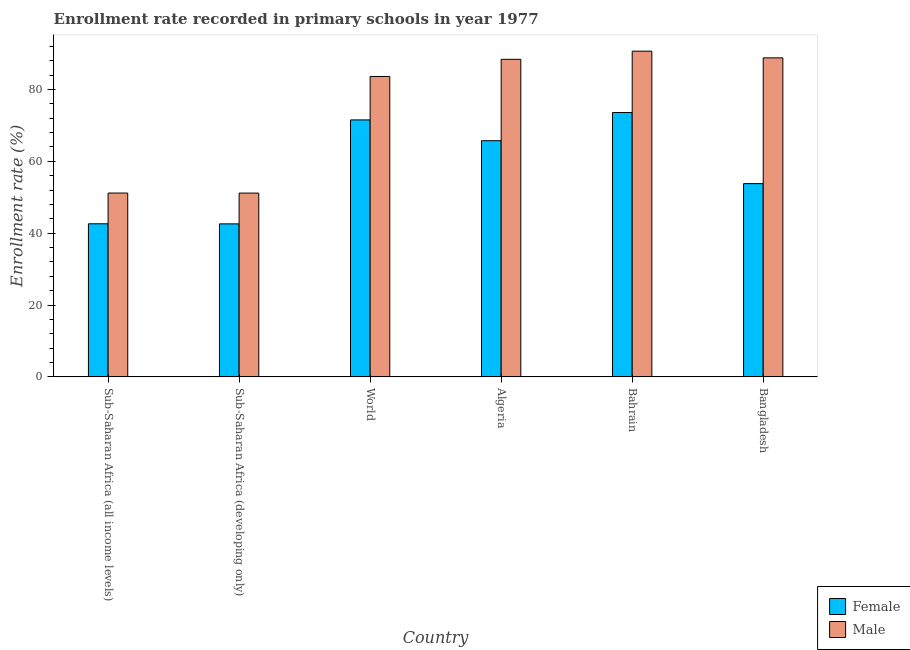How many different coloured bars are there?
Your answer should be very brief. 2. How many bars are there on the 3rd tick from the left?
Provide a short and direct response. 2. What is the label of the 2nd group of bars from the left?
Offer a terse response. Sub-Saharan Africa (developing only). What is the enrollment rate of female students in Bahrain?
Give a very brief answer. 73.57. Across all countries, what is the maximum enrollment rate of male students?
Provide a succinct answer. 90.65. Across all countries, what is the minimum enrollment rate of female students?
Your answer should be compact. 42.58. In which country was the enrollment rate of male students maximum?
Give a very brief answer. Bahrain. In which country was the enrollment rate of male students minimum?
Your answer should be very brief. Sub-Saharan Africa (developing only). What is the total enrollment rate of male students in the graph?
Give a very brief answer. 453.72. What is the difference between the enrollment rate of female students in Bahrain and that in Sub-Saharan Africa (all income levels)?
Provide a succinct answer. 30.97. What is the difference between the enrollment rate of male students in Sub-Saharan Africa (developing only) and the enrollment rate of female students in World?
Keep it short and to the point. -20.36. What is the average enrollment rate of male students per country?
Your answer should be very brief. 75.62. What is the difference between the enrollment rate of male students and enrollment rate of female students in Sub-Saharan Africa (developing only)?
Keep it short and to the point. 8.56. In how many countries, is the enrollment rate of female students greater than 44 %?
Ensure brevity in your answer.  4. What is the ratio of the enrollment rate of female students in Bahrain to that in Sub-Saharan Africa (developing only)?
Give a very brief answer. 1.73. What is the difference between the highest and the second highest enrollment rate of female students?
Offer a terse response. 2.06. What is the difference between the highest and the lowest enrollment rate of male students?
Your response must be concise. 39.5. In how many countries, is the enrollment rate of male students greater than the average enrollment rate of male students taken over all countries?
Provide a short and direct response. 4. What does the 1st bar from the left in Bahrain represents?
Give a very brief answer. Female. How many bars are there?
Your answer should be compact. 12. Does the graph contain any zero values?
Offer a very short reply. No. Does the graph contain grids?
Provide a short and direct response. No. Where does the legend appear in the graph?
Keep it short and to the point. Bottom right. How many legend labels are there?
Make the answer very short. 2. How are the legend labels stacked?
Your response must be concise. Vertical. What is the title of the graph?
Provide a succinct answer. Enrollment rate recorded in primary schools in year 1977. Does "Money lenders" appear as one of the legend labels in the graph?
Offer a very short reply. No. What is the label or title of the Y-axis?
Offer a terse response. Enrollment rate (%). What is the Enrollment rate (%) in Female in Sub-Saharan Africa (all income levels)?
Give a very brief answer. 42.6. What is the Enrollment rate (%) of Male in Sub-Saharan Africa (all income levels)?
Keep it short and to the point. 51.16. What is the Enrollment rate (%) of Female in Sub-Saharan Africa (developing only)?
Provide a short and direct response. 42.58. What is the Enrollment rate (%) in Male in Sub-Saharan Africa (developing only)?
Offer a terse response. 51.15. What is the Enrollment rate (%) of Female in World?
Offer a very short reply. 71.51. What is the Enrollment rate (%) of Male in World?
Offer a terse response. 83.6. What is the Enrollment rate (%) in Female in Algeria?
Keep it short and to the point. 65.73. What is the Enrollment rate (%) in Male in Algeria?
Your answer should be very brief. 88.38. What is the Enrollment rate (%) in Female in Bahrain?
Provide a short and direct response. 73.57. What is the Enrollment rate (%) of Male in Bahrain?
Offer a terse response. 90.65. What is the Enrollment rate (%) in Female in Bangladesh?
Ensure brevity in your answer.  53.78. What is the Enrollment rate (%) of Male in Bangladesh?
Your answer should be very brief. 88.78. Across all countries, what is the maximum Enrollment rate (%) in Female?
Offer a very short reply. 73.57. Across all countries, what is the maximum Enrollment rate (%) of Male?
Offer a very short reply. 90.65. Across all countries, what is the minimum Enrollment rate (%) of Female?
Provide a short and direct response. 42.58. Across all countries, what is the minimum Enrollment rate (%) of Male?
Ensure brevity in your answer.  51.15. What is the total Enrollment rate (%) in Female in the graph?
Keep it short and to the point. 349.77. What is the total Enrollment rate (%) of Male in the graph?
Your answer should be compact. 453.72. What is the difference between the Enrollment rate (%) in Female in Sub-Saharan Africa (all income levels) and that in Sub-Saharan Africa (developing only)?
Provide a succinct answer. 0.02. What is the difference between the Enrollment rate (%) of Male in Sub-Saharan Africa (all income levels) and that in Sub-Saharan Africa (developing only)?
Your response must be concise. 0.01. What is the difference between the Enrollment rate (%) of Female in Sub-Saharan Africa (all income levels) and that in World?
Keep it short and to the point. -28.91. What is the difference between the Enrollment rate (%) in Male in Sub-Saharan Africa (all income levels) and that in World?
Give a very brief answer. -32.44. What is the difference between the Enrollment rate (%) of Female in Sub-Saharan Africa (all income levels) and that in Algeria?
Keep it short and to the point. -23.12. What is the difference between the Enrollment rate (%) of Male in Sub-Saharan Africa (all income levels) and that in Algeria?
Offer a very short reply. -37.22. What is the difference between the Enrollment rate (%) in Female in Sub-Saharan Africa (all income levels) and that in Bahrain?
Your answer should be compact. -30.97. What is the difference between the Enrollment rate (%) of Male in Sub-Saharan Africa (all income levels) and that in Bahrain?
Offer a very short reply. -39.49. What is the difference between the Enrollment rate (%) in Female in Sub-Saharan Africa (all income levels) and that in Bangladesh?
Give a very brief answer. -11.18. What is the difference between the Enrollment rate (%) of Male in Sub-Saharan Africa (all income levels) and that in Bangladesh?
Give a very brief answer. -37.62. What is the difference between the Enrollment rate (%) of Female in Sub-Saharan Africa (developing only) and that in World?
Your answer should be very brief. -28.93. What is the difference between the Enrollment rate (%) in Male in Sub-Saharan Africa (developing only) and that in World?
Your answer should be very brief. -32.46. What is the difference between the Enrollment rate (%) of Female in Sub-Saharan Africa (developing only) and that in Algeria?
Make the answer very short. -23.14. What is the difference between the Enrollment rate (%) of Male in Sub-Saharan Africa (developing only) and that in Algeria?
Give a very brief answer. -37.23. What is the difference between the Enrollment rate (%) in Female in Sub-Saharan Africa (developing only) and that in Bahrain?
Your answer should be very brief. -30.99. What is the difference between the Enrollment rate (%) of Male in Sub-Saharan Africa (developing only) and that in Bahrain?
Offer a terse response. -39.5. What is the difference between the Enrollment rate (%) of Female in Sub-Saharan Africa (developing only) and that in Bangladesh?
Your response must be concise. -11.19. What is the difference between the Enrollment rate (%) of Male in Sub-Saharan Africa (developing only) and that in Bangladesh?
Your answer should be very brief. -37.63. What is the difference between the Enrollment rate (%) of Female in World and that in Algeria?
Give a very brief answer. 5.79. What is the difference between the Enrollment rate (%) in Male in World and that in Algeria?
Provide a succinct answer. -4.78. What is the difference between the Enrollment rate (%) of Female in World and that in Bahrain?
Offer a terse response. -2.06. What is the difference between the Enrollment rate (%) in Male in World and that in Bahrain?
Provide a succinct answer. -7.04. What is the difference between the Enrollment rate (%) of Female in World and that in Bangladesh?
Give a very brief answer. 17.73. What is the difference between the Enrollment rate (%) in Male in World and that in Bangladesh?
Your answer should be very brief. -5.18. What is the difference between the Enrollment rate (%) of Female in Algeria and that in Bahrain?
Your answer should be very brief. -7.84. What is the difference between the Enrollment rate (%) in Male in Algeria and that in Bahrain?
Keep it short and to the point. -2.27. What is the difference between the Enrollment rate (%) of Female in Algeria and that in Bangladesh?
Your answer should be compact. 11.95. What is the difference between the Enrollment rate (%) of Male in Algeria and that in Bangladesh?
Provide a succinct answer. -0.4. What is the difference between the Enrollment rate (%) of Female in Bahrain and that in Bangladesh?
Ensure brevity in your answer.  19.79. What is the difference between the Enrollment rate (%) in Male in Bahrain and that in Bangladesh?
Keep it short and to the point. 1.87. What is the difference between the Enrollment rate (%) of Female in Sub-Saharan Africa (all income levels) and the Enrollment rate (%) of Male in Sub-Saharan Africa (developing only)?
Your response must be concise. -8.55. What is the difference between the Enrollment rate (%) of Female in Sub-Saharan Africa (all income levels) and the Enrollment rate (%) of Male in World?
Your answer should be compact. -41. What is the difference between the Enrollment rate (%) of Female in Sub-Saharan Africa (all income levels) and the Enrollment rate (%) of Male in Algeria?
Offer a very short reply. -45.78. What is the difference between the Enrollment rate (%) in Female in Sub-Saharan Africa (all income levels) and the Enrollment rate (%) in Male in Bahrain?
Provide a short and direct response. -48.04. What is the difference between the Enrollment rate (%) of Female in Sub-Saharan Africa (all income levels) and the Enrollment rate (%) of Male in Bangladesh?
Make the answer very short. -46.18. What is the difference between the Enrollment rate (%) of Female in Sub-Saharan Africa (developing only) and the Enrollment rate (%) of Male in World?
Ensure brevity in your answer.  -41.02. What is the difference between the Enrollment rate (%) in Female in Sub-Saharan Africa (developing only) and the Enrollment rate (%) in Male in Algeria?
Keep it short and to the point. -45.8. What is the difference between the Enrollment rate (%) of Female in Sub-Saharan Africa (developing only) and the Enrollment rate (%) of Male in Bahrain?
Your response must be concise. -48.06. What is the difference between the Enrollment rate (%) in Female in Sub-Saharan Africa (developing only) and the Enrollment rate (%) in Male in Bangladesh?
Your answer should be very brief. -46.2. What is the difference between the Enrollment rate (%) in Female in World and the Enrollment rate (%) in Male in Algeria?
Your answer should be compact. -16.87. What is the difference between the Enrollment rate (%) of Female in World and the Enrollment rate (%) of Male in Bahrain?
Provide a short and direct response. -19.14. What is the difference between the Enrollment rate (%) in Female in World and the Enrollment rate (%) in Male in Bangladesh?
Provide a succinct answer. -17.27. What is the difference between the Enrollment rate (%) of Female in Algeria and the Enrollment rate (%) of Male in Bahrain?
Make the answer very short. -24.92. What is the difference between the Enrollment rate (%) of Female in Algeria and the Enrollment rate (%) of Male in Bangladesh?
Your response must be concise. -23.05. What is the difference between the Enrollment rate (%) in Female in Bahrain and the Enrollment rate (%) in Male in Bangladesh?
Give a very brief answer. -15.21. What is the average Enrollment rate (%) in Female per country?
Your answer should be very brief. 58.3. What is the average Enrollment rate (%) of Male per country?
Provide a short and direct response. 75.62. What is the difference between the Enrollment rate (%) in Female and Enrollment rate (%) in Male in Sub-Saharan Africa (all income levels)?
Keep it short and to the point. -8.56. What is the difference between the Enrollment rate (%) in Female and Enrollment rate (%) in Male in Sub-Saharan Africa (developing only)?
Provide a short and direct response. -8.56. What is the difference between the Enrollment rate (%) of Female and Enrollment rate (%) of Male in World?
Provide a short and direct response. -12.09. What is the difference between the Enrollment rate (%) of Female and Enrollment rate (%) of Male in Algeria?
Your response must be concise. -22.65. What is the difference between the Enrollment rate (%) of Female and Enrollment rate (%) of Male in Bahrain?
Your answer should be very brief. -17.08. What is the difference between the Enrollment rate (%) in Female and Enrollment rate (%) in Male in Bangladesh?
Your answer should be very brief. -35. What is the ratio of the Enrollment rate (%) of Male in Sub-Saharan Africa (all income levels) to that in Sub-Saharan Africa (developing only)?
Provide a short and direct response. 1. What is the ratio of the Enrollment rate (%) in Female in Sub-Saharan Africa (all income levels) to that in World?
Make the answer very short. 0.6. What is the ratio of the Enrollment rate (%) in Male in Sub-Saharan Africa (all income levels) to that in World?
Make the answer very short. 0.61. What is the ratio of the Enrollment rate (%) of Female in Sub-Saharan Africa (all income levels) to that in Algeria?
Your response must be concise. 0.65. What is the ratio of the Enrollment rate (%) of Male in Sub-Saharan Africa (all income levels) to that in Algeria?
Make the answer very short. 0.58. What is the ratio of the Enrollment rate (%) in Female in Sub-Saharan Africa (all income levels) to that in Bahrain?
Keep it short and to the point. 0.58. What is the ratio of the Enrollment rate (%) in Male in Sub-Saharan Africa (all income levels) to that in Bahrain?
Provide a short and direct response. 0.56. What is the ratio of the Enrollment rate (%) of Female in Sub-Saharan Africa (all income levels) to that in Bangladesh?
Keep it short and to the point. 0.79. What is the ratio of the Enrollment rate (%) in Male in Sub-Saharan Africa (all income levels) to that in Bangladesh?
Your answer should be compact. 0.58. What is the ratio of the Enrollment rate (%) of Female in Sub-Saharan Africa (developing only) to that in World?
Offer a very short reply. 0.6. What is the ratio of the Enrollment rate (%) in Male in Sub-Saharan Africa (developing only) to that in World?
Provide a succinct answer. 0.61. What is the ratio of the Enrollment rate (%) of Female in Sub-Saharan Africa (developing only) to that in Algeria?
Keep it short and to the point. 0.65. What is the ratio of the Enrollment rate (%) in Male in Sub-Saharan Africa (developing only) to that in Algeria?
Make the answer very short. 0.58. What is the ratio of the Enrollment rate (%) in Female in Sub-Saharan Africa (developing only) to that in Bahrain?
Offer a terse response. 0.58. What is the ratio of the Enrollment rate (%) in Male in Sub-Saharan Africa (developing only) to that in Bahrain?
Give a very brief answer. 0.56. What is the ratio of the Enrollment rate (%) in Female in Sub-Saharan Africa (developing only) to that in Bangladesh?
Offer a very short reply. 0.79. What is the ratio of the Enrollment rate (%) in Male in Sub-Saharan Africa (developing only) to that in Bangladesh?
Make the answer very short. 0.58. What is the ratio of the Enrollment rate (%) of Female in World to that in Algeria?
Offer a terse response. 1.09. What is the ratio of the Enrollment rate (%) in Male in World to that in Algeria?
Your response must be concise. 0.95. What is the ratio of the Enrollment rate (%) of Female in World to that in Bahrain?
Provide a short and direct response. 0.97. What is the ratio of the Enrollment rate (%) in Male in World to that in Bahrain?
Offer a terse response. 0.92. What is the ratio of the Enrollment rate (%) in Female in World to that in Bangladesh?
Make the answer very short. 1.33. What is the ratio of the Enrollment rate (%) in Male in World to that in Bangladesh?
Ensure brevity in your answer.  0.94. What is the ratio of the Enrollment rate (%) in Female in Algeria to that in Bahrain?
Your answer should be compact. 0.89. What is the ratio of the Enrollment rate (%) of Male in Algeria to that in Bahrain?
Make the answer very short. 0.97. What is the ratio of the Enrollment rate (%) of Female in Algeria to that in Bangladesh?
Your response must be concise. 1.22. What is the ratio of the Enrollment rate (%) of Female in Bahrain to that in Bangladesh?
Make the answer very short. 1.37. What is the difference between the highest and the second highest Enrollment rate (%) in Female?
Your answer should be compact. 2.06. What is the difference between the highest and the second highest Enrollment rate (%) of Male?
Give a very brief answer. 1.87. What is the difference between the highest and the lowest Enrollment rate (%) in Female?
Keep it short and to the point. 30.99. What is the difference between the highest and the lowest Enrollment rate (%) of Male?
Provide a succinct answer. 39.5. 